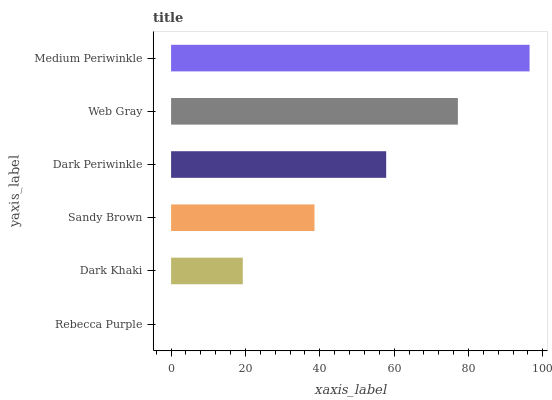Is Rebecca Purple the minimum?
Answer yes or no. Yes. Is Medium Periwinkle the maximum?
Answer yes or no. Yes. Is Dark Khaki the minimum?
Answer yes or no. No. Is Dark Khaki the maximum?
Answer yes or no. No. Is Dark Khaki greater than Rebecca Purple?
Answer yes or no. Yes. Is Rebecca Purple less than Dark Khaki?
Answer yes or no. Yes. Is Rebecca Purple greater than Dark Khaki?
Answer yes or no. No. Is Dark Khaki less than Rebecca Purple?
Answer yes or no. No. Is Dark Periwinkle the high median?
Answer yes or no. Yes. Is Sandy Brown the low median?
Answer yes or no. Yes. Is Medium Periwinkle the high median?
Answer yes or no. No. Is Web Gray the low median?
Answer yes or no. No. 